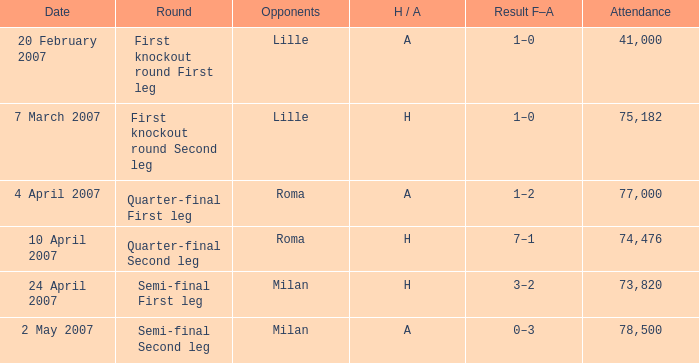Which date has roma as opponent and a H/A of A? 4 April 2007. 